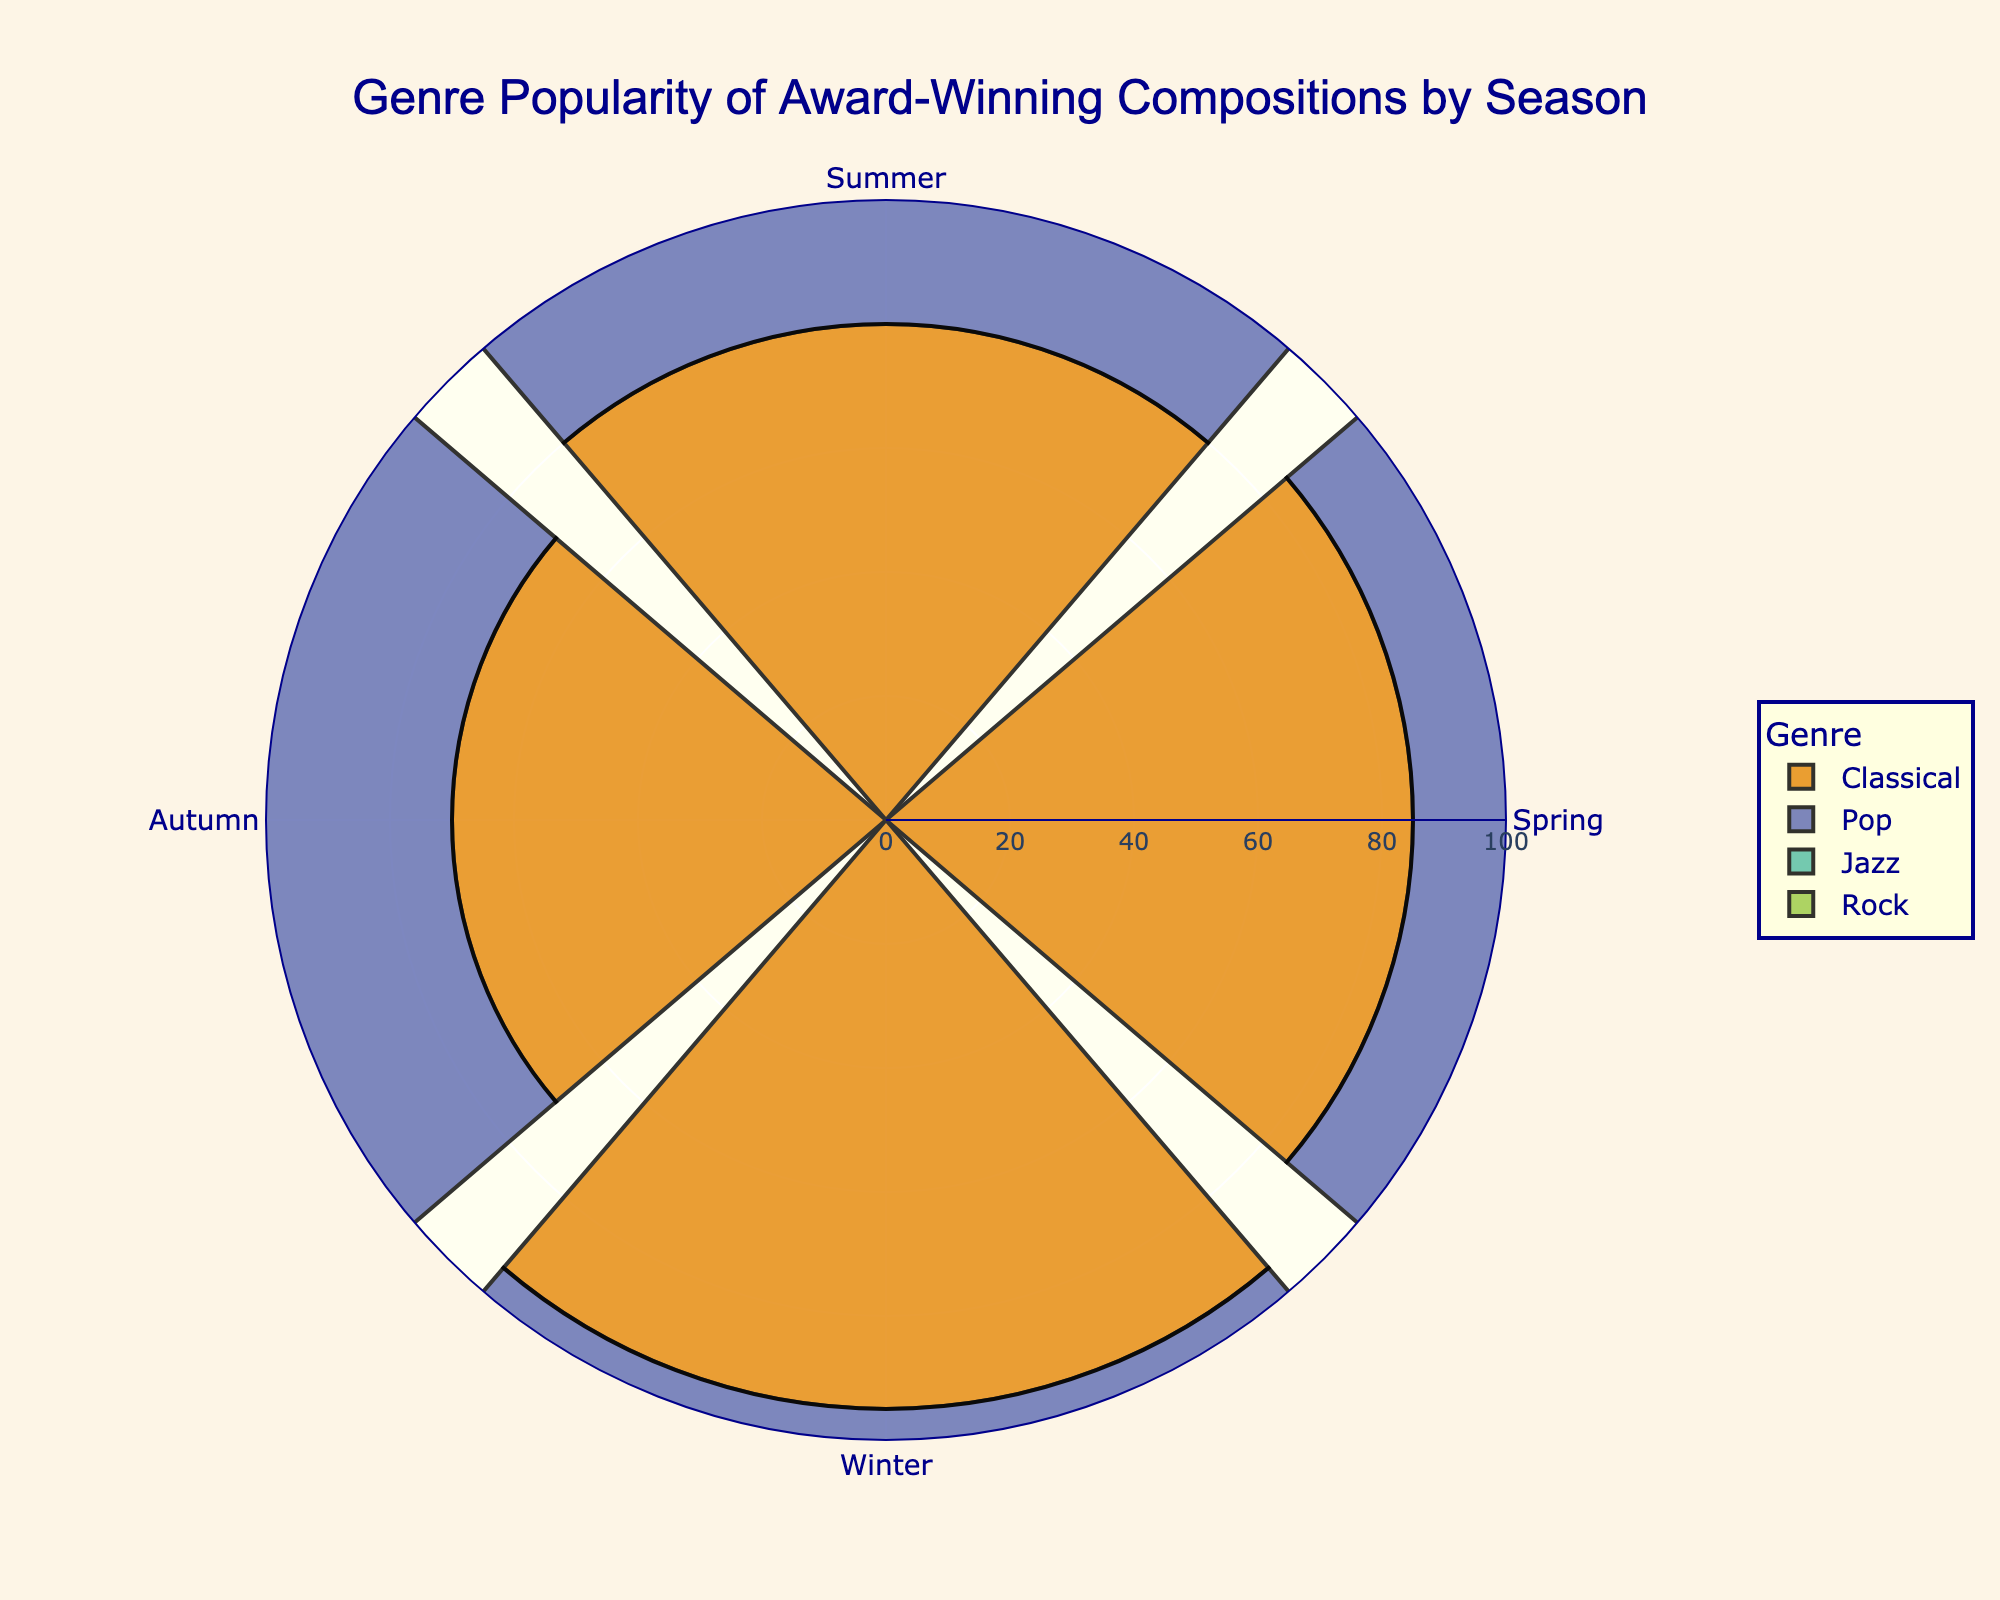How many genres are represented in the figure? Count the different categories for the genre axis. There are Classical, Pop, Jazz, and Rock
Answer: 4 Which season has the highest popularity for Classical compositions? Look at the radial distances (popularity) for Classical compositions across the seasons. Winter has the highest value.
Answer: Winter What is the total popularity of Rock compositions throughout the year? Sum the popularity values for Rock in all seasons: 55 (Spring) + 70 (Summer) + 65 (Autumn) + 85 (Winter) = 275
Answer: 275 Which genre is the least popular during Winter? Compare the radial distances for all genres in Winter. Jazz has the smallest value.
Answer: Jazz What's the average popularity of Pop compositions across all seasons? Sum the popularity values for Pop in all seasons and divide by the number of seasons: (65 + 90 + 75 + 55)/4 = 71.25
Answer: 71.25 In which season is Rock more popular than Jazz? Compare the radial distances of Rock and Jazz in each season to identify where Rock has a greater popularity. Rock is more popular than Jazz in Summer and Winter.
Answer: Summer, Winter Which season has the most balanced popularity distribution across all genres? Look at each season and assess the disparities between the popularity values of different genres. Spring has a relatively balanced distribution (85, 65, 75, 55) compared to other seasons.
Answer: Spring Which genre shows the largest change in popularity between any two seasons? Identify the genre and seasons with the largest difference in radial distance. Pop shows a change from 90 (Summer) to 55 (Winter), a difference of 35.
Answer: Pop What's the difference in popularity for Classical compositions between Spring and Autumn? Subtract the popularity value of Classical in Autumn from that in Spring: 85 (Spring) - 70 (Autumn) = 15
Answer: 15 Is there any season where all genres have a popularity above 50? Check each season to see if all genres have radial distances greater than 50. Spring, Summer, and Autumn all have genres with popularity values above 50.
Answer: Yes 